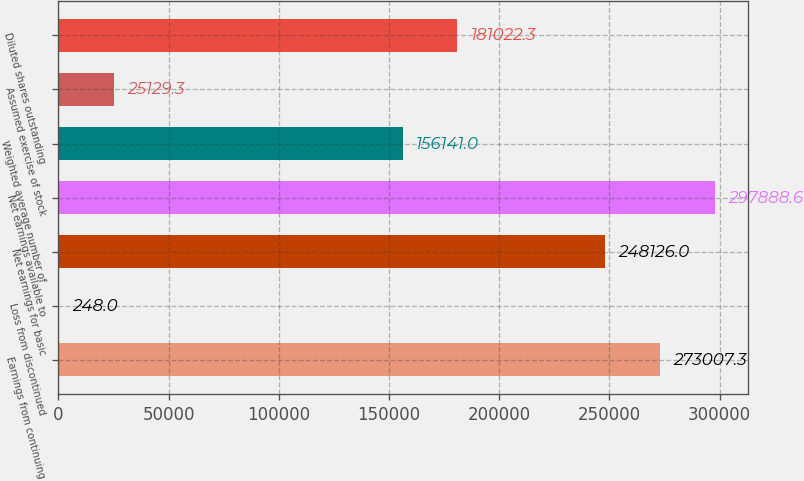Convert chart to OTSL. <chart><loc_0><loc_0><loc_500><loc_500><bar_chart><fcel>Earnings from continuing<fcel>Loss from discontinued<fcel>Net earnings for basic<fcel>Net earnings available to<fcel>Weighted average number of<fcel>Assumed exercise of stock<fcel>Diluted shares outstanding<nl><fcel>273007<fcel>248<fcel>248126<fcel>297889<fcel>156141<fcel>25129.3<fcel>181022<nl></chart> 